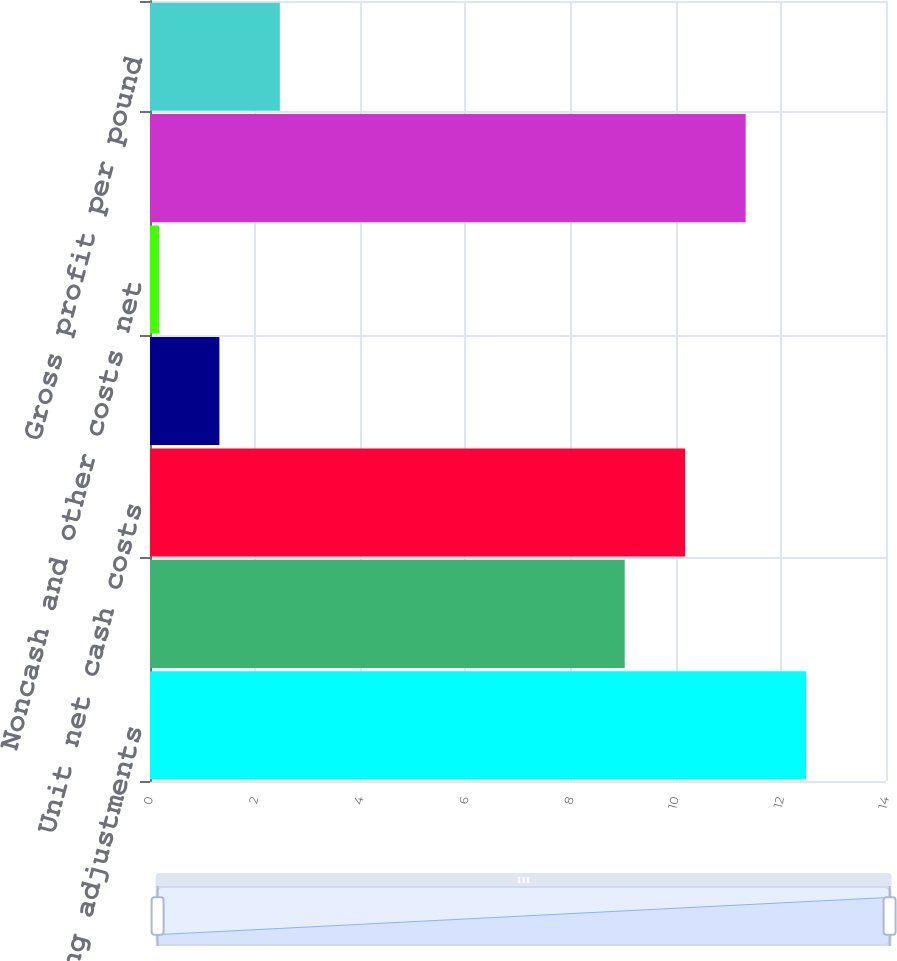<chart> <loc_0><loc_0><loc_500><loc_500><bar_chart><fcel>Revenues excluding adjustments<fcel>and other costs shown below<fcel>Unit net cash costs<fcel>DD&A<fcel>Noncash and other costs net<fcel>Total unit costs<fcel>Gross profit per pound<nl><fcel>12.48<fcel>9.03<fcel>10.18<fcel>1.32<fcel>0.17<fcel>11.33<fcel>2.47<nl></chart> 